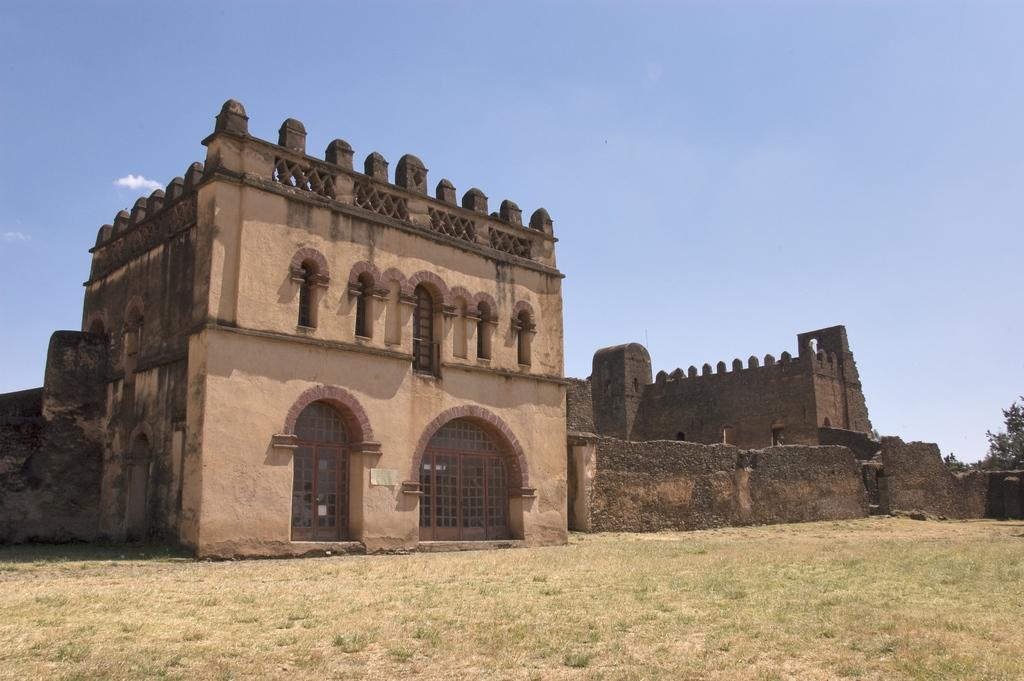Could you give a brief overview of what you see in this image? In the center of the image, we can see forts and in the background, there are trees. At the bottom, there is ground and at the top, there is sky. 